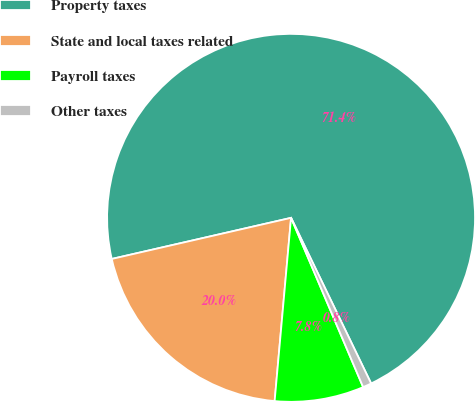<chart> <loc_0><loc_0><loc_500><loc_500><pie_chart><fcel>Property taxes<fcel>State and local taxes related<fcel>Payroll taxes<fcel>Other taxes<nl><fcel>71.42%<fcel>19.99%<fcel>7.83%<fcel>0.76%<nl></chart> 